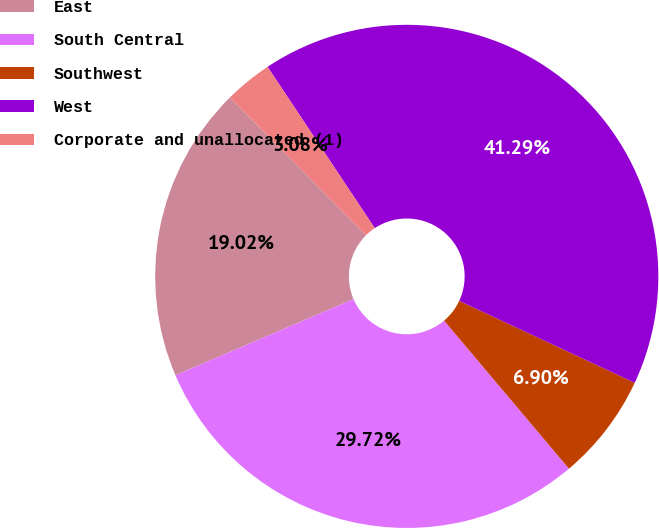Convert chart to OTSL. <chart><loc_0><loc_0><loc_500><loc_500><pie_chart><fcel>East<fcel>South Central<fcel>Southwest<fcel>West<fcel>Corporate and unallocated (1)<nl><fcel>19.02%<fcel>29.72%<fcel>6.9%<fcel>41.29%<fcel>3.08%<nl></chart> 